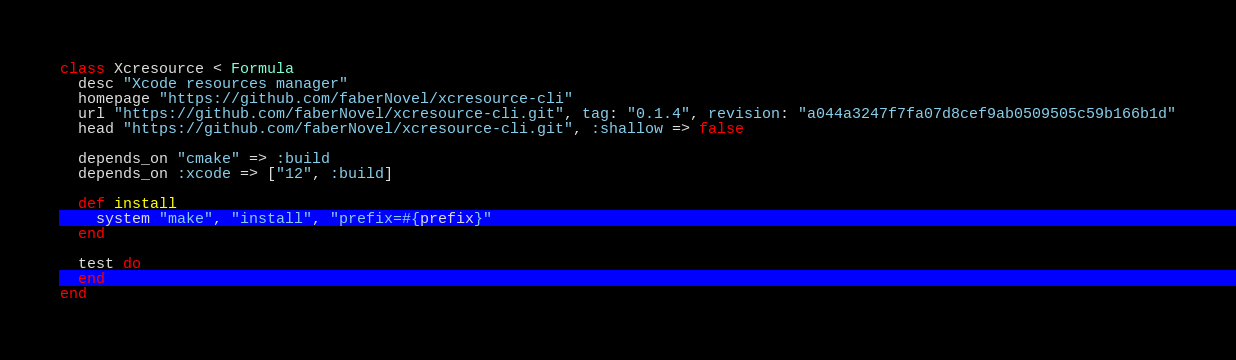<code> <loc_0><loc_0><loc_500><loc_500><_Ruby_>class Xcresource < Formula
  desc "Xcode resources manager"
  homepage "https://github.com/faberNovel/xcresource-cli"
  url "https://github.com/faberNovel/xcresource-cli.git", tag: "0.1.4", revision: "a044a3247f7fa07d8cef9ab0509505c59b166b1d"
  head "https://github.com/faberNovel/xcresource-cli.git", :shallow => false

  depends_on "cmake" => :build
  depends_on :xcode => ["12", :build]

  def install
    system "make", "install", "prefix=#{prefix}"
  end

  test do
  end
end
</code> 